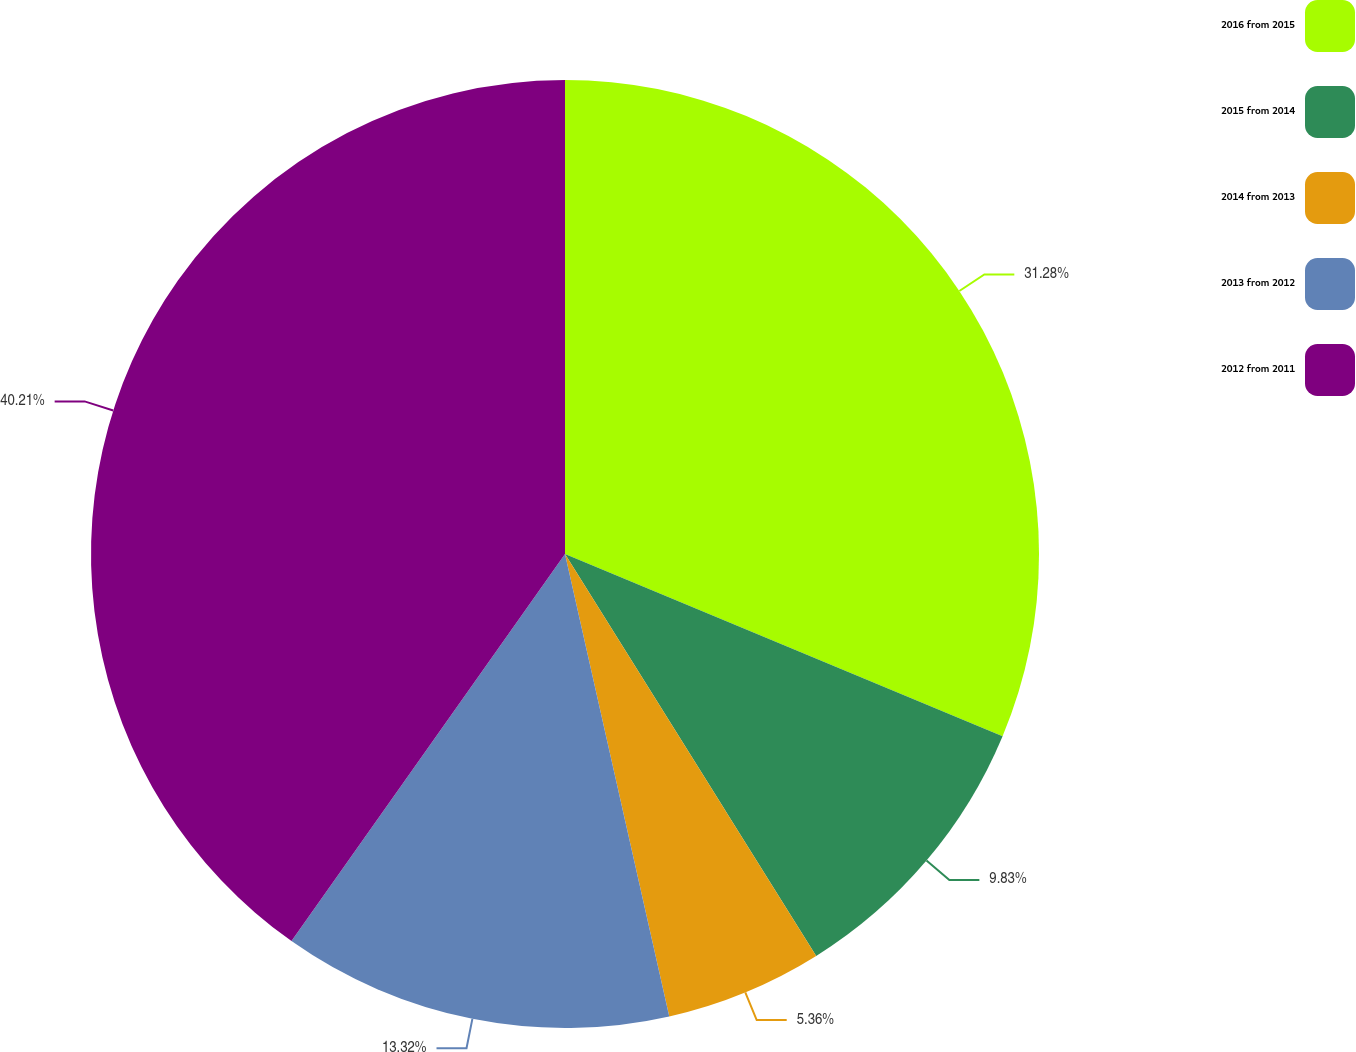Convert chart. <chart><loc_0><loc_0><loc_500><loc_500><pie_chart><fcel>2016 from 2015<fcel>2015 from 2014<fcel>2014 from 2013<fcel>2013 from 2012<fcel>2012 from 2011<nl><fcel>31.28%<fcel>9.83%<fcel>5.36%<fcel>13.32%<fcel>40.21%<nl></chart> 